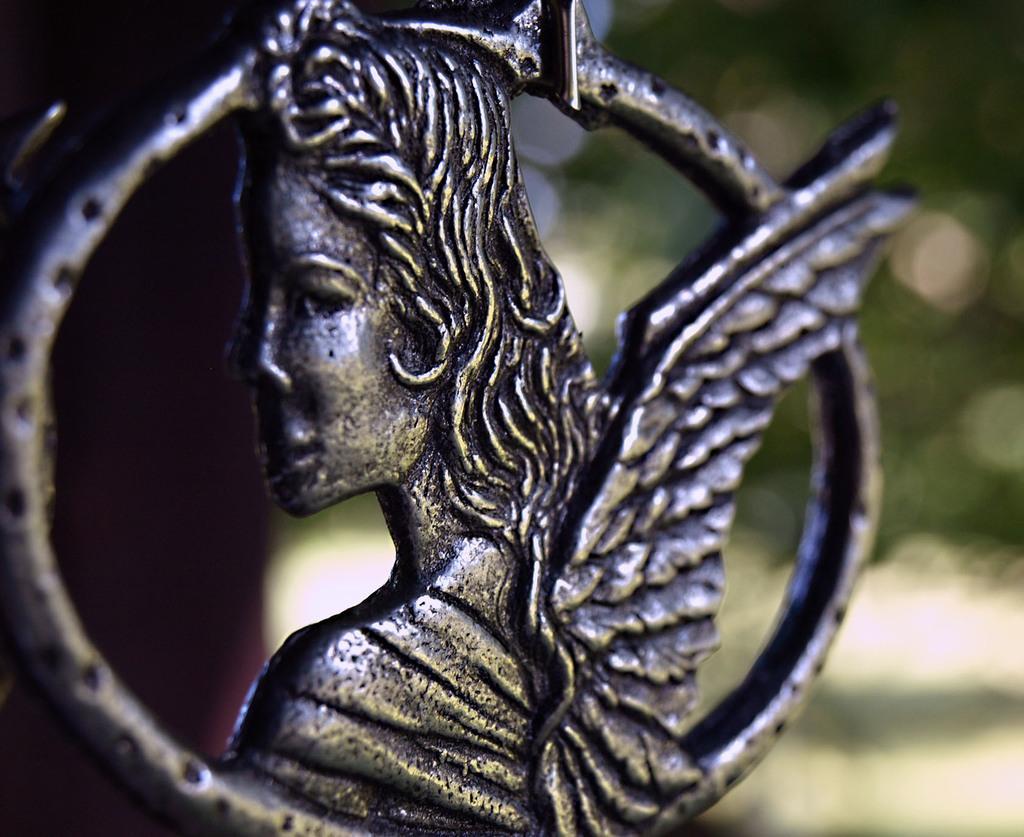Describe this image in one or two sentences. In this image we can see a statue. 